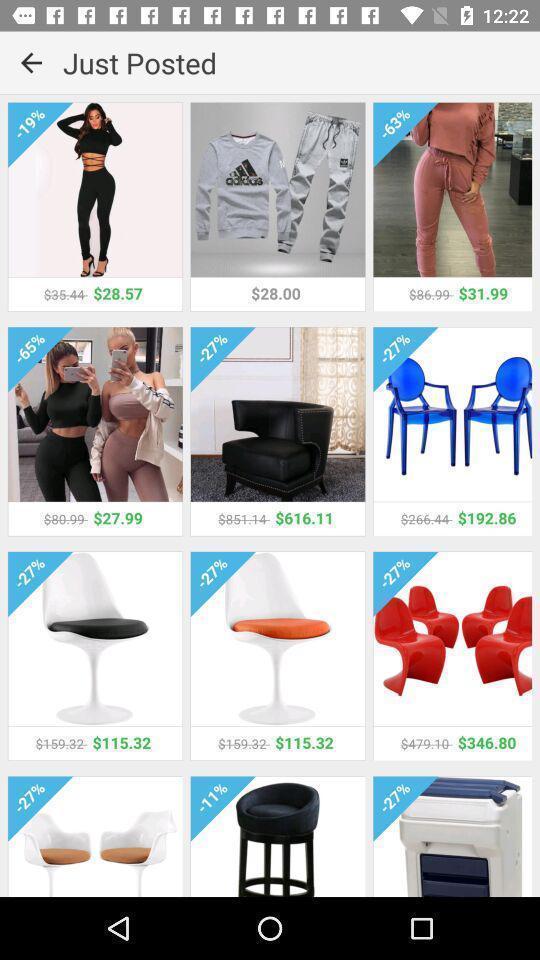What is the overall content of this screenshot? Screen showing prices of different products. 